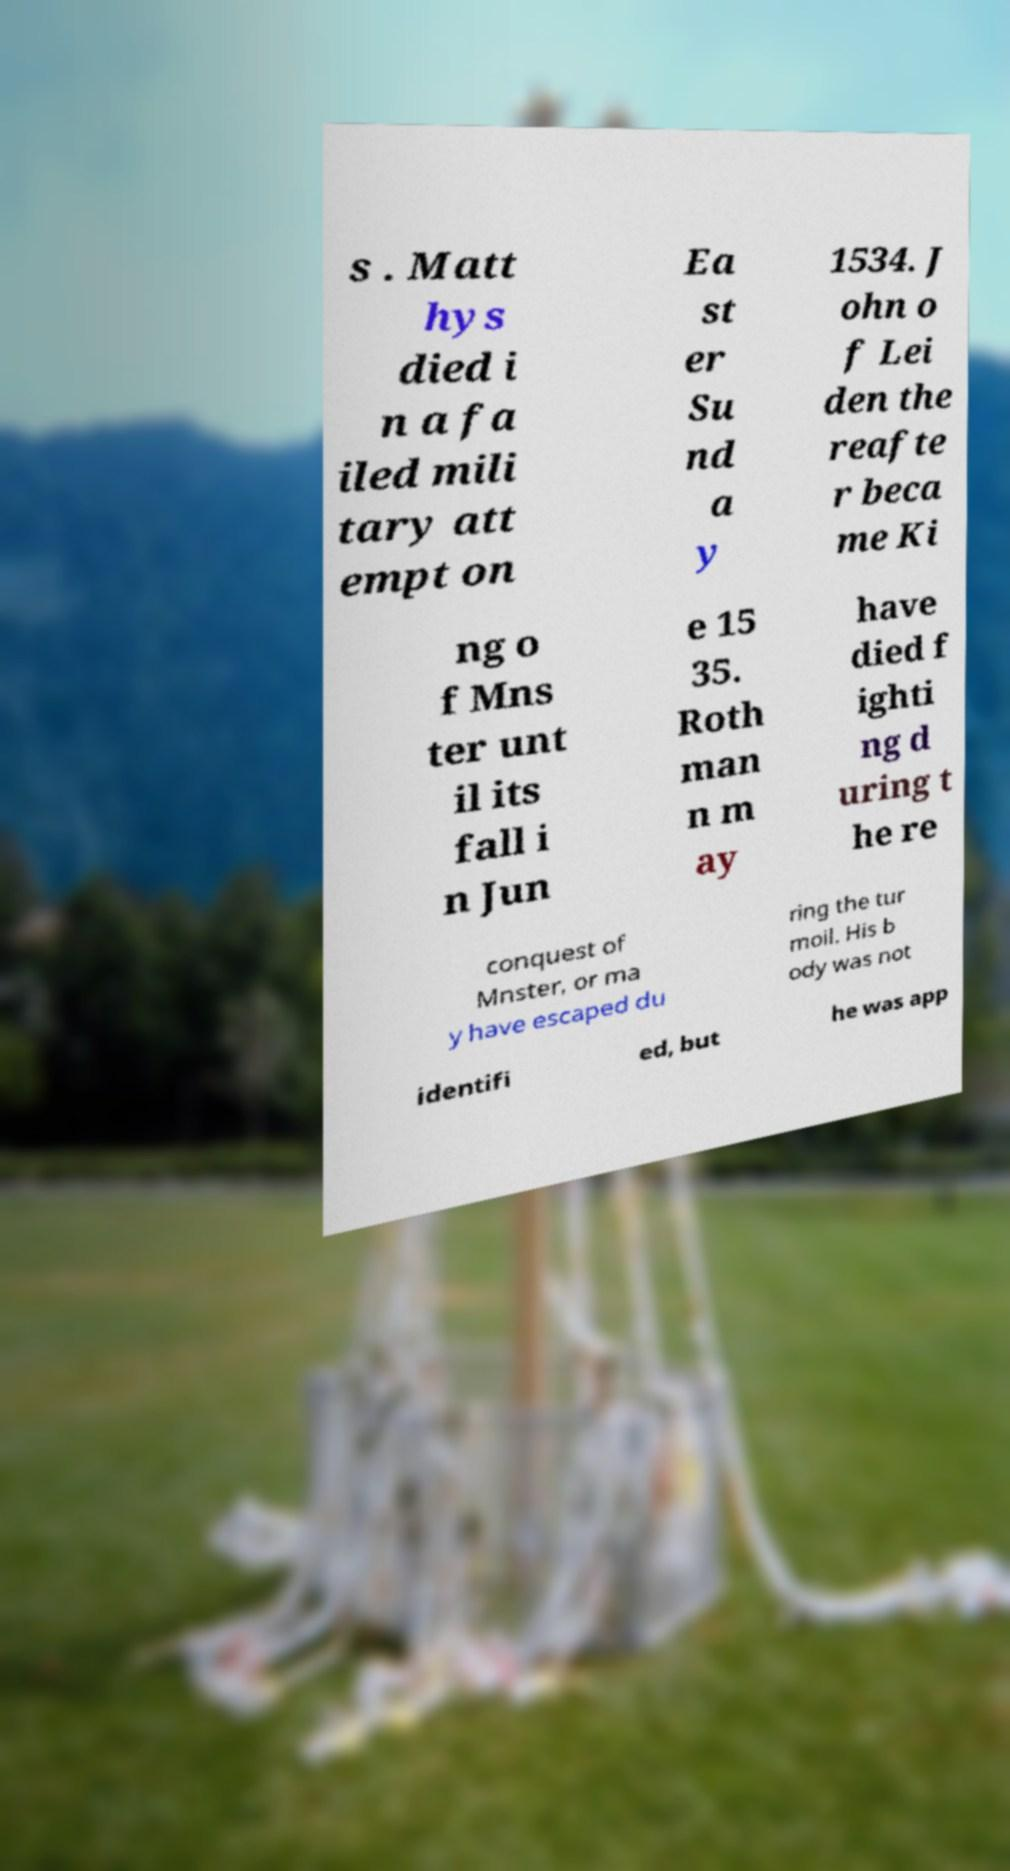Can you read and provide the text displayed in the image?This photo seems to have some interesting text. Can you extract and type it out for me? s . Matt hys died i n a fa iled mili tary att empt on Ea st er Su nd a y 1534. J ohn o f Lei den the reafte r beca me Ki ng o f Mns ter unt il its fall i n Jun e 15 35. Roth man n m ay have died f ighti ng d uring t he re conquest of Mnster, or ma y have escaped du ring the tur moil. His b ody was not identifi ed, but he was app 